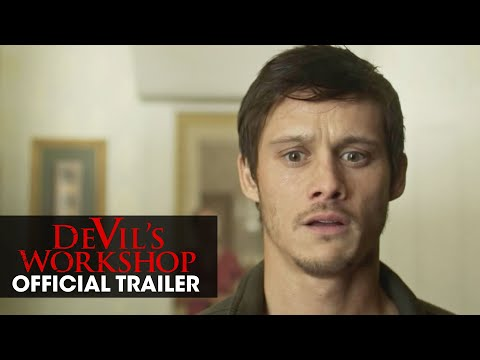Imagine a dialogue this character might have right after this moment. Create a dialogue exchange. Character: *stammering* What... what is that?
Other Character: It's the artifact we were looking for. But why does it look... alive?
Character: I don't know, but we need to take it back. The workshop holds the key to all our questions. Hurry! Now extend this dialogue scene into a more detailed narrative. Character: *stammering* What... what is that?
Other Character: It's the artifact we were looking for. But why does it look... alive?
Character: I don't know, but we need to take it back. The workshop holds the key to all our questions. Hurry!
Other Character: *hesitates* Are you sure we should move it? It might be dangerous.
Character: *nods resolutely* We don't have a choice. If we leave it here, who knows what could happen? We need to understand its power, and the workshop is the only place equipped for that.
Other Character: *carefully lifts the artifact* Alright, but we need to be quick and cautious. It's starting to glow more intensely.
Character: *takes a deep breath* Let's move! Every second counts. 